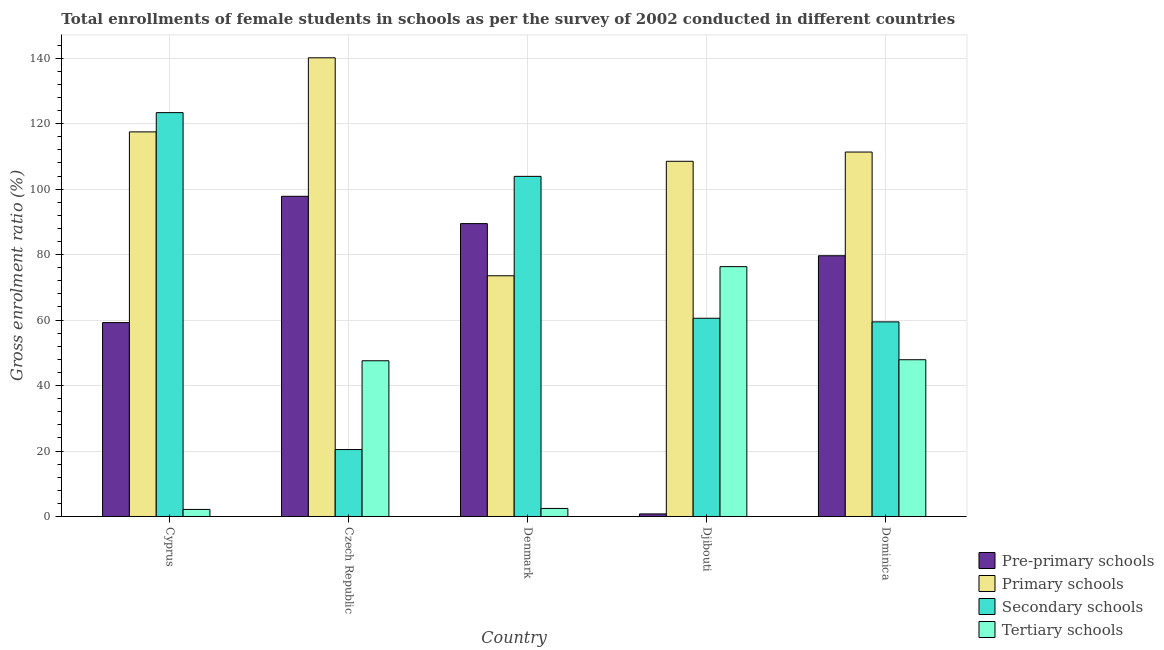Are the number of bars per tick equal to the number of legend labels?
Keep it short and to the point. Yes. How many bars are there on the 3rd tick from the right?
Provide a succinct answer. 4. What is the label of the 2nd group of bars from the left?
Your answer should be compact. Czech Republic. In how many cases, is the number of bars for a given country not equal to the number of legend labels?
Keep it short and to the point. 0. What is the gross enrolment ratio(female) in secondary schools in Dominica?
Offer a very short reply. 59.46. Across all countries, what is the maximum gross enrolment ratio(female) in pre-primary schools?
Provide a succinct answer. 97.82. Across all countries, what is the minimum gross enrolment ratio(female) in primary schools?
Offer a terse response. 73.54. In which country was the gross enrolment ratio(female) in secondary schools maximum?
Make the answer very short. Cyprus. In which country was the gross enrolment ratio(female) in secondary schools minimum?
Keep it short and to the point. Czech Republic. What is the total gross enrolment ratio(female) in primary schools in the graph?
Provide a succinct answer. 551.02. What is the difference between the gross enrolment ratio(female) in tertiary schools in Cyprus and that in Djibouti?
Ensure brevity in your answer.  -74.18. What is the difference between the gross enrolment ratio(female) in tertiary schools in Denmark and the gross enrolment ratio(female) in pre-primary schools in Cyprus?
Give a very brief answer. -56.78. What is the average gross enrolment ratio(female) in pre-primary schools per country?
Make the answer very short. 65.39. What is the difference between the gross enrolment ratio(female) in pre-primary schools and gross enrolment ratio(female) in primary schools in Cyprus?
Your response must be concise. -58.27. What is the ratio of the gross enrolment ratio(female) in secondary schools in Cyprus to that in Denmark?
Provide a succinct answer. 1.19. What is the difference between the highest and the second highest gross enrolment ratio(female) in tertiary schools?
Your response must be concise. 28.44. What is the difference between the highest and the lowest gross enrolment ratio(female) in primary schools?
Your answer should be compact. 66.59. In how many countries, is the gross enrolment ratio(female) in pre-primary schools greater than the average gross enrolment ratio(female) in pre-primary schools taken over all countries?
Make the answer very short. 3. Is it the case that in every country, the sum of the gross enrolment ratio(female) in primary schools and gross enrolment ratio(female) in pre-primary schools is greater than the sum of gross enrolment ratio(female) in tertiary schools and gross enrolment ratio(female) in secondary schools?
Your answer should be very brief. No. What does the 2nd bar from the left in Czech Republic represents?
Ensure brevity in your answer.  Primary schools. What does the 3rd bar from the right in Dominica represents?
Offer a very short reply. Primary schools. Is it the case that in every country, the sum of the gross enrolment ratio(female) in pre-primary schools and gross enrolment ratio(female) in primary schools is greater than the gross enrolment ratio(female) in secondary schools?
Offer a very short reply. Yes. Are all the bars in the graph horizontal?
Your answer should be compact. No. What is the difference between two consecutive major ticks on the Y-axis?
Make the answer very short. 20. Does the graph contain any zero values?
Your answer should be compact. No. How many legend labels are there?
Make the answer very short. 4. How are the legend labels stacked?
Your answer should be compact. Vertical. What is the title of the graph?
Make the answer very short. Total enrollments of female students in schools as per the survey of 2002 conducted in different countries. Does "Oil" appear as one of the legend labels in the graph?
Your answer should be very brief. No. What is the Gross enrolment ratio (%) in Pre-primary schools in Cyprus?
Offer a very short reply. 59.23. What is the Gross enrolment ratio (%) of Primary schools in Cyprus?
Make the answer very short. 117.5. What is the Gross enrolment ratio (%) of Secondary schools in Cyprus?
Provide a succinct answer. 123.38. What is the Gross enrolment ratio (%) of Tertiary schools in Cyprus?
Ensure brevity in your answer.  2.16. What is the Gross enrolment ratio (%) in Pre-primary schools in Czech Republic?
Your answer should be compact. 97.82. What is the Gross enrolment ratio (%) of Primary schools in Czech Republic?
Provide a succinct answer. 140.13. What is the Gross enrolment ratio (%) in Secondary schools in Czech Republic?
Offer a very short reply. 20.45. What is the Gross enrolment ratio (%) of Tertiary schools in Czech Republic?
Keep it short and to the point. 47.57. What is the Gross enrolment ratio (%) in Pre-primary schools in Denmark?
Offer a terse response. 89.48. What is the Gross enrolment ratio (%) in Primary schools in Denmark?
Provide a succinct answer. 73.54. What is the Gross enrolment ratio (%) of Secondary schools in Denmark?
Your answer should be very brief. 103.91. What is the Gross enrolment ratio (%) in Tertiary schools in Denmark?
Your answer should be very brief. 2.46. What is the Gross enrolment ratio (%) of Pre-primary schools in Djibouti?
Ensure brevity in your answer.  0.79. What is the Gross enrolment ratio (%) in Primary schools in Djibouti?
Your response must be concise. 108.51. What is the Gross enrolment ratio (%) of Secondary schools in Djibouti?
Offer a terse response. 60.56. What is the Gross enrolment ratio (%) of Tertiary schools in Djibouti?
Give a very brief answer. 76.33. What is the Gross enrolment ratio (%) in Pre-primary schools in Dominica?
Provide a succinct answer. 79.66. What is the Gross enrolment ratio (%) of Primary schools in Dominica?
Ensure brevity in your answer.  111.34. What is the Gross enrolment ratio (%) of Secondary schools in Dominica?
Ensure brevity in your answer.  59.46. What is the Gross enrolment ratio (%) of Tertiary schools in Dominica?
Your answer should be compact. 47.89. Across all countries, what is the maximum Gross enrolment ratio (%) in Pre-primary schools?
Your answer should be compact. 97.82. Across all countries, what is the maximum Gross enrolment ratio (%) in Primary schools?
Provide a succinct answer. 140.13. Across all countries, what is the maximum Gross enrolment ratio (%) of Secondary schools?
Make the answer very short. 123.38. Across all countries, what is the maximum Gross enrolment ratio (%) in Tertiary schools?
Provide a short and direct response. 76.33. Across all countries, what is the minimum Gross enrolment ratio (%) in Pre-primary schools?
Make the answer very short. 0.79. Across all countries, what is the minimum Gross enrolment ratio (%) of Primary schools?
Your answer should be compact. 73.54. Across all countries, what is the minimum Gross enrolment ratio (%) in Secondary schools?
Your response must be concise. 20.45. Across all countries, what is the minimum Gross enrolment ratio (%) in Tertiary schools?
Offer a terse response. 2.16. What is the total Gross enrolment ratio (%) in Pre-primary schools in the graph?
Offer a terse response. 326.97. What is the total Gross enrolment ratio (%) of Primary schools in the graph?
Offer a terse response. 551.02. What is the total Gross enrolment ratio (%) in Secondary schools in the graph?
Give a very brief answer. 367.75. What is the total Gross enrolment ratio (%) in Tertiary schools in the graph?
Give a very brief answer. 176.41. What is the difference between the Gross enrolment ratio (%) in Pre-primary schools in Cyprus and that in Czech Republic?
Offer a terse response. -38.58. What is the difference between the Gross enrolment ratio (%) in Primary schools in Cyprus and that in Czech Republic?
Your response must be concise. -22.63. What is the difference between the Gross enrolment ratio (%) in Secondary schools in Cyprus and that in Czech Republic?
Offer a terse response. 102.93. What is the difference between the Gross enrolment ratio (%) of Tertiary schools in Cyprus and that in Czech Republic?
Your answer should be very brief. -45.42. What is the difference between the Gross enrolment ratio (%) in Pre-primary schools in Cyprus and that in Denmark?
Give a very brief answer. -30.24. What is the difference between the Gross enrolment ratio (%) in Primary schools in Cyprus and that in Denmark?
Provide a short and direct response. 43.96. What is the difference between the Gross enrolment ratio (%) in Secondary schools in Cyprus and that in Denmark?
Your answer should be compact. 19.47. What is the difference between the Gross enrolment ratio (%) of Tertiary schools in Cyprus and that in Denmark?
Offer a very short reply. -0.3. What is the difference between the Gross enrolment ratio (%) in Pre-primary schools in Cyprus and that in Djibouti?
Give a very brief answer. 58.44. What is the difference between the Gross enrolment ratio (%) in Primary schools in Cyprus and that in Djibouti?
Your answer should be very brief. 8.99. What is the difference between the Gross enrolment ratio (%) in Secondary schools in Cyprus and that in Djibouti?
Offer a very short reply. 62.82. What is the difference between the Gross enrolment ratio (%) in Tertiary schools in Cyprus and that in Djibouti?
Your answer should be compact. -74.18. What is the difference between the Gross enrolment ratio (%) in Pre-primary schools in Cyprus and that in Dominica?
Make the answer very short. -20.43. What is the difference between the Gross enrolment ratio (%) in Primary schools in Cyprus and that in Dominica?
Ensure brevity in your answer.  6.16. What is the difference between the Gross enrolment ratio (%) in Secondary schools in Cyprus and that in Dominica?
Your response must be concise. 63.92. What is the difference between the Gross enrolment ratio (%) of Tertiary schools in Cyprus and that in Dominica?
Your answer should be compact. -45.73. What is the difference between the Gross enrolment ratio (%) in Pre-primary schools in Czech Republic and that in Denmark?
Keep it short and to the point. 8.34. What is the difference between the Gross enrolment ratio (%) in Primary schools in Czech Republic and that in Denmark?
Your response must be concise. 66.59. What is the difference between the Gross enrolment ratio (%) of Secondary schools in Czech Republic and that in Denmark?
Make the answer very short. -83.46. What is the difference between the Gross enrolment ratio (%) of Tertiary schools in Czech Republic and that in Denmark?
Make the answer very short. 45.12. What is the difference between the Gross enrolment ratio (%) of Pre-primary schools in Czech Republic and that in Djibouti?
Provide a short and direct response. 97.03. What is the difference between the Gross enrolment ratio (%) of Primary schools in Czech Republic and that in Djibouti?
Give a very brief answer. 31.61. What is the difference between the Gross enrolment ratio (%) in Secondary schools in Czech Republic and that in Djibouti?
Provide a short and direct response. -40.11. What is the difference between the Gross enrolment ratio (%) in Tertiary schools in Czech Republic and that in Djibouti?
Make the answer very short. -28.76. What is the difference between the Gross enrolment ratio (%) of Pre-primary schools in Czech Republic and that in Dominica?
Keep it short and to the point. 18.16. What is the difference between the Gross enrolment ratio (%) of Primary schools in Czech Republic and that in Dominica?
Offer a terse response. 28.79. What is the difference between the Gross enrolment ratio (%) in Secondary schools in Czech Republic and that in Dominica?
Provide a short and direct response. -39.01. What is the difference between the Gross enrolment ratio (%) of Tertiary schools in Czech Republic and that in Dominica?
Provide a succinct answer. -0.31. What is the difference between the Gross enrolment ratio (%) of Pre-primary schools in Denmark and that in Djibouti?
Give a very brief answer. 88.69. What is the difference between the Gross enrolment ratio (%) in Primary schools in Denmark and that in Djibouti?
Provide a short and direct response. -34.97. What is the difference between the Gross enrolment ratio (%) in Secondary schools in Denmark and that in Djibouti?
Offer a very short reply. 43.35. What is the difference between the Gross enrolment ratio (%) in Tertiary schools in Denmark and that in Djibouti?
Offer a very short reply. -73.88. What is the difference between the Gross enrolment ratio (%) of Pre-primary schools in Denmark and that in Dominica?
Keep it short and to the point. 9.82. What is the difference between the Gross enrolment ratio (%) in Primary schools in Denmark and that in Dominica?
Make the answer very short. -37.8. What is the difference between the Gross enrolment ratio (%) in Secondary schools in Denmark and that in Dominica?
Give a very brief answer. 44.45. What is the difference between the Gross enrolment ratio (%) of Tertiary schools in Denmark and that in Dominica?
Your answer should be compact. -45.43. What is the difference between the Gross enrolment ratio (%) in Pre-primary schools in Djibouti and that in Dominica?
Your answer should be compact. -78.87. What is the difference between the Gross enrolment ratio (%) of Primary schools in Djibouti and that in Dominica?
Keep it short and to the point. -2.83. What is the difference between the Gross enrolment ratio (%) of Secondary schools in Djibouti and that in Dominica?
Ensure brevity in your answer.  1.1. What is the difference between the Gross enrolment ratio (%) in Tertiary schools in Djibouti and that in Dominica?
Make the answer very short. 28.44. What is the difference between the Gross enrolment ratio (%) in Pre-primary schools in Cyprus and the Gross enrolment ratio (%) in Primary schools in Czech Republic?
Offer a very short reply. -80.89. What is the difference between the Gross enrolment ratio (%) in Pre-primary schools in Cyprus and the Gross enrolment ratio (%) in Secondary schools in Czech Republic?
Keep it short and to the point. 38.78. What is the difference between the Gross enrolment ratio (%) in Pre-primary schools in Cyprus and the Gross enrolment ratio (%) in Tertiary schools in Czech Republic?
Your answer should be compact. 11.66. What is the difference between the Gross enrolment ratio (%) of Primary schools in Cyprus and the Gross enrolment ratio (%) of Secondary schools in Czech Republic?
Keep it short and to the point. 97.05. What is the difference between the Gross enrolment ratio (%) in Primary schools in Cyprus and the Gross enrolment ratio (%) in Tertiary schools in Czech Republic?
Your answer should be very brief. 69.92. What is the difference between the Gross enrolment ratio (%) in Secondary schools in Cyprus and the Gross enrolment ratio (%) in Tertiary schools in Czech Republic?
Provide a succinct answer. 75.8. What is the difference between the Gross enrolment ratio (%) in Pre-primary schools in Cyprus and the Gross enrolment ratio (%) in Primary schools in Denmark?
Your response must be concise. -14.31. What is the difference between the Gross enrolment ratio (%) of Pre-primary schools in Cyprus and the Gross enrolment ratio (%) of Secondary schools in Denmark?
Your answer should be very brief. -44.68. What is the difference between the Gross enrolment ratio (%) of Pre-primary schools in Cyprus and the Gross enrolment ratio (%) of Tertiary schools in Denmark?
Provide a succinct answer. 56.78. What is the difference between the Gross enrolment ratio (%) in Primary schools in Cyprus and the Gross enrolment ratio (%) in Secondary schools in Denmark?
Give a very brief answer. 13.59. What is the difference between the Gross enrolment ratio (%) in Primary schools in Cyprus and the Gross enrolment ratio (%) in Tertiary schools in Denmark?
Your answer should be compact. 115.04. What is the difference between the Gross enrolment ratio (%) in Secondary schools in Cyprus and the Gross enrolment ratio (%) in Tertiary schools in Denmark?
Keep it short and to the point. 120.92. What is the difference between the Gross enrolment ratio (%) in Pre-primary schools in Cyprus and the Gross enrolment ratio (%) in Primary schools in Djibouti?
Offer a terse response. -49.28. What is the difference between the Gross enrolment ratio (%) of Pre-primary schools in Cyprus and the Gross enrolment ratio (%) of Secondary schools in Djibouti?
Provide a short and direct response. -1.33. What is the difference between the Gross enrolment ratio (%) of Pre-primary schools in Cyprus and the Gross enrolment ratio (%) of Tertiary schools in Djibouti?
Keep it short and to the point. -17.1. What is the difference between the Gross enrolment ratio (%) of Primary schools in Cyprus and the Gross enrolment ratio (%) of Secondary schools in Djibouti?
Your answer should be very brief. 56.94. What is the difference between the Gross enrolment ratio (%) of Primary schools in Cyprus and the Gross enrolment ratio (%) of Tertiary schools in Djibouti?
Your answer should be very brief. 41.17. What is the difference between the Gross enrolment ratio (%) of Secondary schools in Cyprus and the Gross enrolment ratio (%) of Tertiary schools in Djibouti?
Provide a succinct answer. 47.04. What is the difference between the Gross enrolment ratio (%) of Pre-primary schools in Cyprus and the Gross enrolment ratio (%) of Primary schools in Dominica?
Make the answer very short. -52.11. What is the difference between the Gross enrolment ratio (%) in Pre-primary schools in Cyprus and the Gross enrolment ratio (%) in Secondary schools in Dominica?
Provide a short and direct response. -0.23. What is the difference between the Gross enrolment ratio (%) of Pre-primary schools in Cyprus and the Gross enrolment ratio (%) of Tertiary schools in Dominica?
Provide a short and direct response. 11.34. What is the difference between the Gross enrolment ratio (%) in Primary schools in Cyprus and the Gross enrolment ratio (%) in Secondary schools in Dominica?
Your response must be concise. 58.04. What is the difference between the Gross enrolment ratio (%) in Primary schools in Cyprus and the Gross enrolment ratio (%) in Tertiary schools in Dominica?
Provide a succinct answer. 69.61. What is the difference between the Gross enrolment ratio (%) of Secondary schools in Cyprus and the Gross enrolment ratio (%) of Tertiary schools in Dominica?
Give a very brief answer. 75.49. What is the difference between the Gross enrolment ratio (%) in Pre-primary schools in Czech Republic and the Gross enrolment ratio (%) in Primary schools in Denmark?
Offer a very short reply. 24.28. What is the difference between the Gross enrolment ratio (%) in Pre-primary schools in Czech Republic and the Gross enrolment ratio (%) in Secondary schools in Denmark?
Your response must be concise. -6.09. What is the difference between the Gross enrolment ratio (%) in Pre-primary schools in Czech Republic and the Gross enrolment ratio (%) in Tertiary schools in Denmark?
Your answer should be compact. 95.36. What is the difference between the Gross enrolment ratio (%) in Primary schools in Czech Republic and the Gross enrolment ratio (%) in Secondary schools in Denmark?
Offer a very short reply. 36.22. What is the difference between the Gross enrolment ratio (%) in Primary schools in Czech Republic and the Gross enrolment ratio (%) in Tertiary schools in Denmark?
Your response must be concise. 137.67. What is the difference between the Gross enrolment ratio (%) in Secondary schools in Czech Republic and the Gross enrolment ratio (%) in Tertiary schools in Denmark?
Keep it short and to the point. 17.99. What is the difference between the Gross enrolment ratio (%) of Pre-primary schools in Czech Republic and the Gross enrolment ratio (%) of Primary schools in Djibouti?
Ensure brevity in your answer.  -10.7. What is the difference between the Gross enrolment ratio (%) of Pre-primary schools in Czech Republic and the Gross enrolment ratio (%) of Secondary schools in Djibouti?
Give a very brief answer. 37.26. What is the difference between the Gross enrolment ratio (%) in Pre-primary schools in Czech Republic and the Gross enrolment ratio (%) in Tertiary schools in Djibouti?
Provide a succinct answer. 21.48. What is the difference between the Gross enrolment ratio (%) in Primary schools in Czech Republic and the Gross enrolment ratio (%) in Secondary schools in Djibouti?
Your response must be concise. 79.57. What is the difference between the Gross enrolment ratio (%) of Primary schools in Czech Republic and the Gross enrolment ratio (%) of Tertiary schools in Djibouti?
Provide a succinct answer. 63.8. What is the difference between the Gross enrolment ratio (%) of Secondary schools in Czech Republic and the Gross enrolment ratio (%) of Tertiary schools in Djibouti?
Your response must be concise. -55.88. What is the difference between the Gross enrolment ratio (%) of Pre-primary schools in Czech Republic and the Gross enrolment ratio (%) of Primary schools in Dominica?
Your answer should be compact. -13.52. What is the difference between the Gross enrolment ratio (%) in Pre-primary schools in Czech Republic and the Gross enrolment ratio (%) in Secondary schools in Dominica?
Provide a short and direct response. 38.36. What is the difference between the Gross enrolment ratio (%) in Pre-primary schools in Czech Republic and the Gross enrolment ratio (%) in Tertiary schools in Dominica?
Your answer should be compact. 49.93. What is the difference between the Gross enrolment ratio (%) of Primary schools in Czech Republic and the Gross enrolment ratio (%) of Secondary schools in Dominica?
Offer a terse response. 80.67. What is the difference between the Gross enrolment ratio (%) in Primary schools in Czech Republic and the Gross enrolment ratio (%) in Tertiary schools in Dominica?
Offer a very short reply. 92.24. What is the difference between the Gross enrolment ratio (%) in Secondary schools in Czech Republic and the Gross enrolment ratio (%) in Tertiary schools in Dominica?
Your response must be concise. -27.44. What is the difference between the Gross enrolment ratio (%) of Pre-primary schools in Denmark and the Gross enrolment ratio (%) of Primary schools in Djibouti?
Keep it short and to the point. -19.04. What is the difference between the Gross enrolment ratio (%) of Pre-primary schools in Denmark and the Gross enrolment ratio (%) of Secondary schools in Djibouti?
Your answer should be very brief. 28.91. What is the difference between the Gross enrolment ratio (%) of Pre-primary schools in Denmark and the Gross enrolment ratio (%) of Tertiary schools in Djibouti?
Keep it short and to the point. 13.14. What is the difference between the Gross enrolment ratio (%) of Primary schools in Denmark and the Gross enrolment ratio (%) of Secondary schools in Djibouti?
Offer a terse response. 12.98. What is the difference between the Gross enrolment ratio (%) of Primary schools in Denmark and the Gross enrolment ratio (%) of Tertiary schools in Djibouti?
Provide a succinct answer. -2.79. What is the difference between the Gross enrolment ratio (%) of Secondary schools in Denmark and the Gross enrolment ratio (%) of Tertiary schools in Djibouti?
Offer a very short reply. 27.58. What is the difference between the Gross enrolment ratio (%) in Pre-primary schools in Denmark and the Gross enrolment ratio (%) in Primary schools in Dominica?
Provide a succinct answer. -21.87. What is the difference between the Gross enrolment ratio (%) of Pre-primary schools in Denmark and the Gross enrolment ratio (%) of Secondary schools in Dominica?
Ensure brevity in your answer.  30.02. What is the difference between the Gross enrolment ratio (%) of Pre-primary schools in Denmark and the Gross enrolment ratio (%) of Tertiary schools in Dominica?
Give a very brief answer. 41.59. What is the difference between the Gross enrolment ratio (%) of Primary schools in Denmark and the Gross enrolment ratio (%) of Secondary schools in Dominica?
Provide a succinct answer. 14.08. What is the difference between the Gross enrolment ratio (%) in Primary schools in Denmark and the Gross enrolment ratio (%) in Tertiary schools in Dominica?
Make the answer very short. 25.65. What is the difference between the Gross enrolment ratio (%) in Secondary schools in Denmark and the Gross enrolment ratio (%) in Tertiary schools in Dominica?
Make the answer very short. 56.02. What is the difference between the Gross enrolment ratio (%) in Pre-primary schools in Djibouti and the Gross enrolment ratio (%) in Primary schools in Dominica?
Ensure brevity in your answer.  -110.55. What is the difference between the Gross enrolment ratio (%) in Pre-primary schools in Djibouti and the Gross enrolment ratio (%) in Secondary schools in Dominica?
Provide a short and direct response. -58.67. What is the difference between the Gross enrolment ratio (%) in Pre-primary schools in Djibouti and the Gross enrolment ratio (%) in Tertiary schools in Dominica?
Give a very brief answer. -47.1. What is the difference between the Gross enrolment ratio (%) in Primary schools in Djibouti and the Gross enrolment ratio (%) in Secondary schools in Dominica?
Ensure brevity in your answer.  49.06. What is the difference between the Gross enrolment ratio (%) of Primary schools in Djibouti and the Gross enrolment ratio (%) of Tertiary schools in Dominica?
Your answer should be compact. 60.62. What is the difference between the Gross enrolment ratio (%) in Secondary schools in Djibouti and the Gross enrolment ratio (%) in Tertiary schools in Dominica?
Make the answer very short. 12.67. What is the average Gross enrolment ratio (%) in Pre-primary schools per country?
Offer a very short reply. 65.39. What is the average Gross enrolment ratio (%) in Primary schools per country?
Provide a succinct answer. 110.2. What is the average Gross enrolment ratio (%) in Secondary schools per country?
Offer a terse response. 73.55. What is the average Gross enrolment ratio (%) of Tertiary schools per country?
Provide a short and direct response. 35.28. What is the difference between the Gross enrolment ratio (%) of Pre-primary schools and Gross enrolment ratio (%) of Primary schools in Cyprus?
Ensure brevity in your answer.  -58.27. What is the difference between the Gross enrolment ratio (%) of Pre-primary schools and Gross enrolment ratio (%) of Secondary schools in Cyprus?
Ensure brevity in your answer.  -64.14. What is the difference between the Gross enrolment ratio (%) of Pre-primary schools and Gross enrolment ratio (%) of Tertiary schools in Cyprus?
Keep it short and to the point. 57.08. What is the difference between the Gross enrolment ratio (%) in Primary schools and Gross enrolment ratio (%) in Secondary schools in Cyprus?
Provide a short and direct response. -5.88. What is the difference between the Gross enrolment ratio (%) in Primary schools and Gross enrolment ratio (%) in Tertiary schools in Cyprus?
Your answer should be compact. 115.34. What is the difference between the Gross enrolment ratio (%) in Secondary schools and Gross enrolment ratio (%) in Tertiary schools in Cyprus?
Keep it short and to the point. 121.22. What is the difference between the Gross enrolment ratio (%) of Pre-primary schools and Gross enrolment ratio (%) of Primary schools in Czech Republic?
Offer a very short reply. -42.31. What is the difference between the Gross enrolment ratio (%) of Pre-primary schools and Gross enrolment ratio (%) of Secondary schools in Czech Republic?
Make the answer very short. 77.37. What is the difference between the Gross enrolment ratio (%) in Pre-primary schools and Gross enrolment ratio (%) in Tertiary schools in Czech Republic?
Give a very brief answer. 50.24. What is the difference between the Gross enrolment ratio (%) of Primary schools and Gross enrolment ratio (%) of Secondary schools in Czech Republic?
Your response must be concise. 119.68. What is the difference between the Gross enrolment ratio (%) of Primary schools and Gross enrolment ratio (%) of Tertiary schools in Czech Republic?
Your answer should be very brief. 92.55. What is the difference between the Gross enrolment ratio (%) in Secondary schools and Gross enrolment ratio (%) in Tertiary schools in Czech Republic?
Your response must be concise. -27.13. What is the difference between the Gross enrolment ratio (%) of Pre-primary schools and Gross enrolment ratio (%) of Primary schools in Denmark?
Ensure brevity in your answer.  15.94. What is the difference between the Gross enrolment ratio (%) in Pre-primary schools and Gross enrolment ratio (%) in Secondary schools in Denmark?
Ensure brevity in your answer.  -14.43. What is the difference between the Gross enrolment ratio (%) in Pre-primary schools and Gross enrolment ratio (%) in Tertiary schools in Denmark?
Provide a short and direct response. 87.02. What is the difference between the Gross enrolment ratio (%) of Primary schools and Gross enrolment ratio (%) of Secondary schools in Denmark?
Give a very brief answer. -30.37. What is the difference between the Gross enrolment ratio (%) in Primary schools and Gross enrolment ratio (%) in Tertiary schools in Denmark?
Offer a terse response. 71.08. What is the difference between the Gross enrolment ratio (%) in Secondary schools and Gross enrolment ratio (%) in Tertiary schools in Denmark?
Provide a succinct answer. 101.45. What is the difference between the Gross enrolment ratio (%) in Pre-primary schools and Gross enrolment ratio (%) in Primary schools in Djibouti?
Keep it short and to the point. -107.73. What is the difference between the Gross enrolment ratio (%) of Pre-primary schools and Gross enrolment ratio (%) of Secondary schools in Djibouti?
Offer a very short reply. -59.77. What is the difference between the Gross enrolment ratio (%) in Pre-primary schools and Gross enrolment ratio (%) in Tertiary schools in Djibouti?
Keep it short and to the point. -75.54. What is the difference between the Gross enrolment ratio (%) of Primary schools and Gross enrolment ratio (%) of Secondary schools in Djibouti?
Ensure brevity in your answer.  47.95. What is the difference between the Gross enrolment ratio (%) of Primary schools and Gross enrolment ratio (%) of Tertiary schools in Djibouti?
Your answer should be very brief. 32.18. What is the difference between the Gross enrolment ratio (%) of Secondary schools and Gross enrolment ratio (%) of Tertiary schools in Djibouti?
Your response must be concise. -15.77. What is the difference between the Gross enrolment ratio (%) in Pre-primary schools and Gross enrolment ratio (%) in Primary schools in Dominica?
Your answer should be very brief. -31.68. What is the difference between the Gross enrolment ratio (%) in Pre-primary schools and Gross enrolment ratio (%) in Secondary schools in Dominica?
Offer a terse response. 20.2. What is the difference between the Gross enrolment ratio (%) in Pre-primary schools and Gross enrolment ratio (%) in Tertiary schools in Dominica?
Provide a succinct answer. 31.77. What is the difference between the Gross enrolment ratio (%) in Primary schools and Gross enrolment ratio (%) in Secondary schools in Dominica?
Make the answer very short. 51.88. What is the difference between the Gross enrolment ratio (%) of Primary schools and Gross enrolment ratio (%) of Tertiary schools in Dominica?
Keep it short and to the point. 63.45. What is the difference between the Gross enrolment ratio (%) in Secondary schools and Gross enrolment ratio (%) in Tertiary schools in Dominica?
Provide a short and direct response. 11.57. What is the ratio of the Gross enrolment ratio (%) in Pre-primary schools in Cyprus to that in Czech Republic?
Your response must be concise. 0.61. What is the ratio of the Gross enrolment ratio (%) of Primary schools in Cyprus to that in Czech Republic?
Make the answer very short. 0.84. What is the ratio of the Gross enrolment ratio (%) in Secondary schools in Cyprus to that in Czech Republic?
Offer a terse response. 6.03. What is the ratio of the Gross enrolment ratio (%) of Tertiary schools in Cyprus to that in Czech Republic?
Keep it short and to the point. 0.05. What is the ratio of the Gross enrolment ratio (%) in Pre-primary schools in Cyprus to that in Denmark?
Make the answer very short. 0.66. What is the ratio of the Gross enrolment ratio (%) of Primary schools in Cyprus to that in Denmark?
Provide a succinct answer. 1.6. What is the ratio of the Gross enrolment ratio (%) in Secondary schools in Cyprus to that in Denmark?
Provide a short and direct response. 1.19. What is the ratio of the Gross enrolment ratio (%) in Tertiary schools in Cyprus to that in Denmark?
Make the answer very short. 0.88. What is the ratio of the Gross enrolment ratio (%) in Pre-primary schools in Cyprus to that in Djibouti?
Keep it short and to the point. 75.25. What is the ratio of the Gross enrolment ratio (%) of Primary schools in Cyprus to that in Djibouti?
Ensure brevity in your answer.  1.08. What is the ratio of the Gross enrolment ratio (%) in Secondary schools in Cyprus to that in Djibouti?
Give a very brief answer. 2.04. What is the ratio of the Gross enrolment ratio (%) of Tertiary schools in Cyprus to that in Djibouti?
Offer a terse response. 0.03. What is the ratio of the Gross enrolment ratio (%) in Pre-primary schools in Cyprus to that in Dominica?
Keep it short and to the point. 0.74. What is the ratio of the Gross enrolment ratio (%) of Primary schools in Cyprus to that in Dominica?
Provide a succinct answer. 1.06. What is the ratio of the Gross enrolment ratio (%) of Secondary schools in Cyprus to that in Dominica?
Give a very brief answer. 2.08. What is the ratio of the Gross enrolment ratio (%) of Tertiary schools in Cyprus to that in Dominica?
Give a very brief answer. 0.04. What is the ratio of the Gross enrolment ratio (%) in Pre-primary schools in Czech Republic to that in Denmark?
Keep it short and to the point. 1.09. What is the ratio of the Gross enrolment ratio (%) in Primary schools in Czech Republic to that in Denmark?
Provide a succinct answer. 1.91. What is the ratio of the Gross enrolment ratio (%) in Secondary schools in Czech Republic to that in Denmark?
Provide a succinct answer. 0.2. What is the ratio of the Gross enrolment ratio (%) in Tertiary schools in Czech Republic to that in Denmark?
Provide a succinct answer. 19.37. What is the ratio of the Gross enrolment ratio (%) in Pre-primary schools in Czech Republic to that in Djibouti?
Give a very brief answer. 124.27. What is the ratio of the Gross enrolment ratio (%) of Primary schools in Czech Republic to that in Djibouti?
Provide a short and direct response. 1.29. What is the ratio of the Gross enrolment ratio (%) of Secondary schools in Czech Republic to that in Djibouti?
Ensure brevity in your answer.  0.34. What is the ratio of the Gross enrolment ratio (%) of Tertiary schools in Czech Republic to that in Djibouti?
Provide a succinct answer. 0.62. What is the ratio of the Gross enrolment ratio (%) of Pre-primary schools in Czech Republic to that in Dominica?
Your answer should be compact. 1.23. What is the ratio of the Gross enrolment ratio (%) of Primary schools in Czech Republic to that in Dominica?
Provide a short and direct response. 1.26. What is the ratio of the Gross enrolment ratio (%) of Secondary schools in Czech Republic to that in Dominica?
Provide a short and direct response. 0.34. What is the ratio of the Gross enrolment ratio (%) in Pre-primary schools in Denmark to that in Djibouti?
Your answer should be very brief. 113.67. What is the ratio of the Gross enrolment ratio (%) in Primary schools in Denmark to that in Djibouti?
Make the answer very short. 0.68. What is the ratio of the Gross enrolment ratio (%) of Secondary schools in Denmark to that in Djibouti?
Your answer should be compact. 1.72. What is the ratio of the Gross enrolment ratio (%) in Tertiary schools in Denmark to that in Djibouti?
Your answer should be compact. 0.03. What is the ratio of the Gross enrolment ratio (%) in Pre-primary schools in Denmark to that in Dominica?
Offer a very short reply. 1.12. What is the ratio of the Gross enrolment ratio (%) of Primary schools in Denmark to that in Dominica?
Give a very brief answer. 0.66. What is the ratio of the Gross enrolment ratio (%) in Secondary schools in Denmark to that in Dominica?
Provide a succinct answer. 1.75. What is the ratio of the Gross enrolment ratio (%) of Tertiary schools in Denmark to that in Dominica?
Your answer should be very brief. 0.05. What is the ratio of the Gross enrolment ratio (%) of Pre-primary schools in Djibouti to that in Dominica?
Offer a very short reply. 0.01. What is the ratio of the Gross enrolment ratio (%) in Primary schools in Djibouti to that in Dominica?
Keep it short and to the point. 0.97. What is the ratio of the Gross enrolment ratio (%) of Secondary schools in Djibouti to that in Dominica?
Ensure brevity in your answer.  1.02. What is the ratio of the Gross enrolment ratio (%) in Tertiary schools in Djibouti to that in Dominica?
Provide a short and direct response. 1.59. What is the difference between the highest and the second highest Gross enrolment ratio (%) of Pre-primary schools?
Your answer should be very brief. 8.34. What is the difference between the highest and the second highest Gross enrolment ratio (%) of Primary schools?
Offer a terse response. 22.63. What is the difference between the highest and the second highest Gross enrolment ratio (%) in Secondary schools?
Keep it short and to the point. 19.47. What is the difference between the highest and the second highest Gross enrolment ratio (%) in Tertiary schools?
Provide a short and direct response. 28.44. What is the difference between the highest and the lowest Gross enrolment ratio (%) in Pre-primary schools?
Your answer should be compact. 97.03. What is the difference between the highest and the lowest Gross enrolment ratio (%) of Primary schools?
Your response must be concise. 66.59. What is the difference between the highest and the lowest Gross enrolment ratio (%) of Secondary schools?
Make the answer very short. 102.93. What is the difference between the highest and the lowest Gross enrolment ratio (%) of Tertiary schools?
Provide a short and direct response. 74.18. 